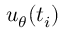Convert formula to latex. <formula><loc_0><loc_0><loc_500><loc_500>{ u _ { \theta } } ( t _ { i } )</formula> 